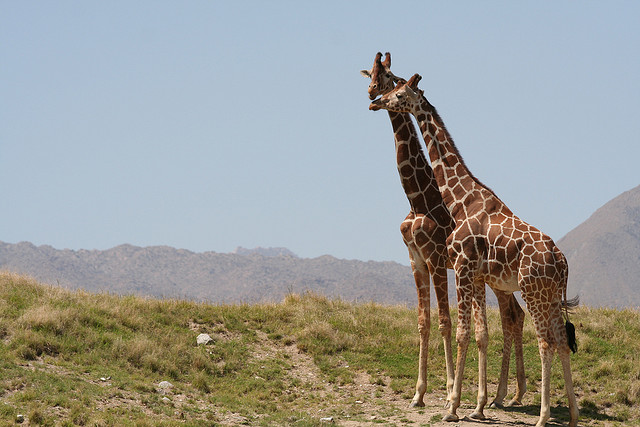<image>Are they both male? I am not sure if they are both male. It can be either yes or no. Are they both male? It is unknown if they are both male. 